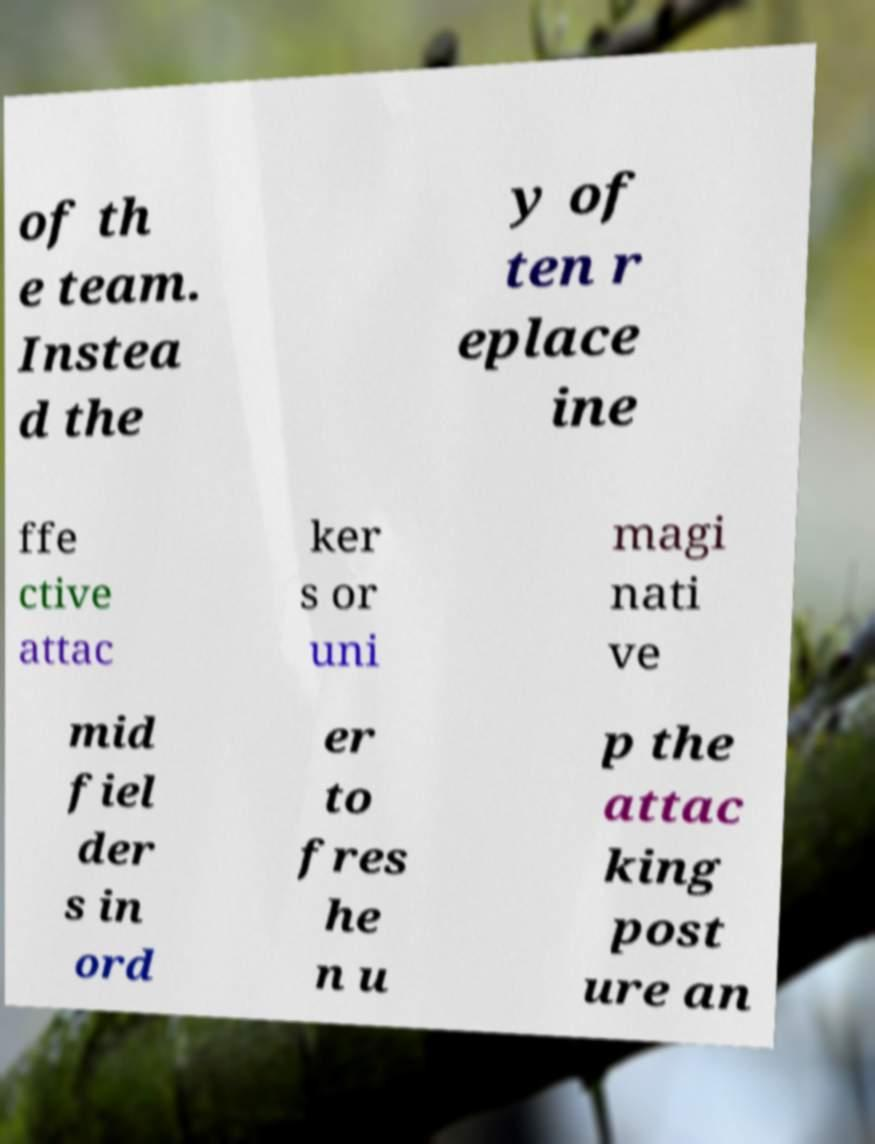Could you assist in decoding the text presented in this image and type it out clearly? of th e team. Instea d the y of ten r eplace ine ffe ctive attac ker s or uni magi nati ve mid fiel der s in ord er to fres he n u p the attac king post ure an 